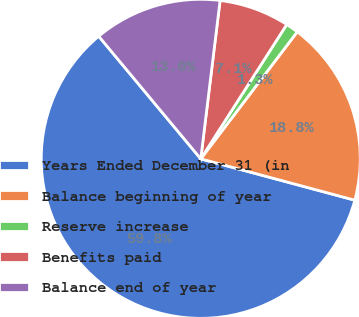<chart> <loc_0><loc_0><loc_500><loc_500><pie_chart><fcel>Years Ended December 31 (in<fcel>Balance beginning of year<fcel>Reserve increase<fcel>Benefits paid<fcel>Balance end of year<nl><fcel>59.78%<fcel>18.83%<fcel>1.28%<fcel>7.13%<fcel>12.98%<nl></chart> 